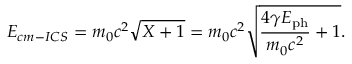Convert formula to latex. <formula><loc_0><loc_0><loc_500><loc_500>E _ { c m - I C S } = m _ { 0 } c ^ { 2 } \sqrt { X + 1 } = m _ { 0 } c ^ { 2 } \sqrt { \frac { 4 \gamma E _ { p h } } { m _ { 0 } c ^ { 2 } } + 1 } .</formula> 